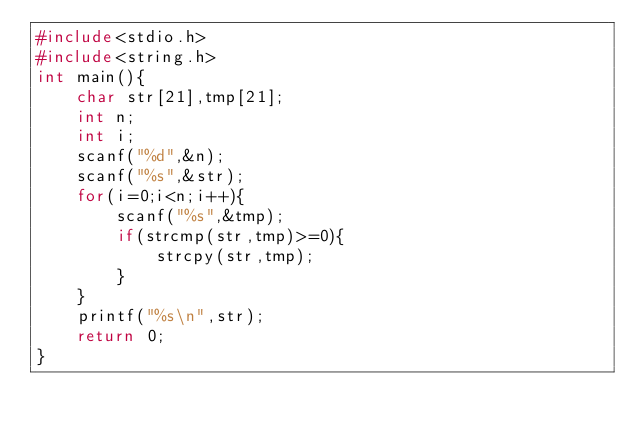<code> <loc_0><loc_0><loc_500><loc_500><_C_>#include<stdio.h>
#include<string.h>
int main(){
    char str[21],tmp[21];
    int n;
    int i;
    scanf("%d",&n);
    scanf("%s",&str);
    for(i=0;i<n;i++){
        scanf("%s",&tmp);
        if(strcmp(str,tmp)>=0){
            strcpy(str,tmp);
        }
    }
    printf("%s\n",str);
    return 0;
}</code> 